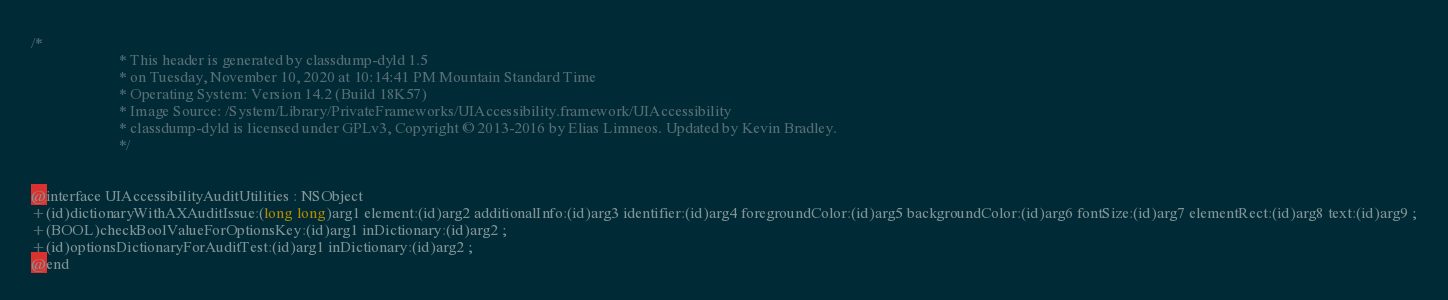Convert code to text. <code><loc_0><loc_0><loc_500><loc_500><_C_>/*
                       * This header is generated by classdump-dyld 1.5
                       * on Tuesday, November 10, 2020 at 10:14:41 PM Mountain Standard Time
                       * Operating System: Version 14.2 (Build 18K57)
                       * Image Source: /System/Library/PrivateFrameworks/UIAccessibility.framework/UIAccessibility
                       * classdump-dyld is licensed under GPLv3, Copyright © 2013-2016 by Elias Limneos. Updated by Kevin Bradley.
                       */


@interface UIAccessibilityAuditUtilities : NSObject
+(id)dictionaryWithAXAuditIssue:(long long)arg1 element:(id)arg2 additionalInfo:(id)arg3 identifier:(id)arg4 foregroundColor:(id)arg5 backgroundColor:(id)arg6 fontSize:(id)arg7 elementRect:(id)arg8 text:(id)arg9 ;
+(BOOL)checkBoolValueForOptionsKey:(id)arg1 inDictionary:(id)arg2 ;
+(id)optionsDictionaryForAuditTest:(id)arg1 inDictionary:(id)arg2 ;
@end

</code> 